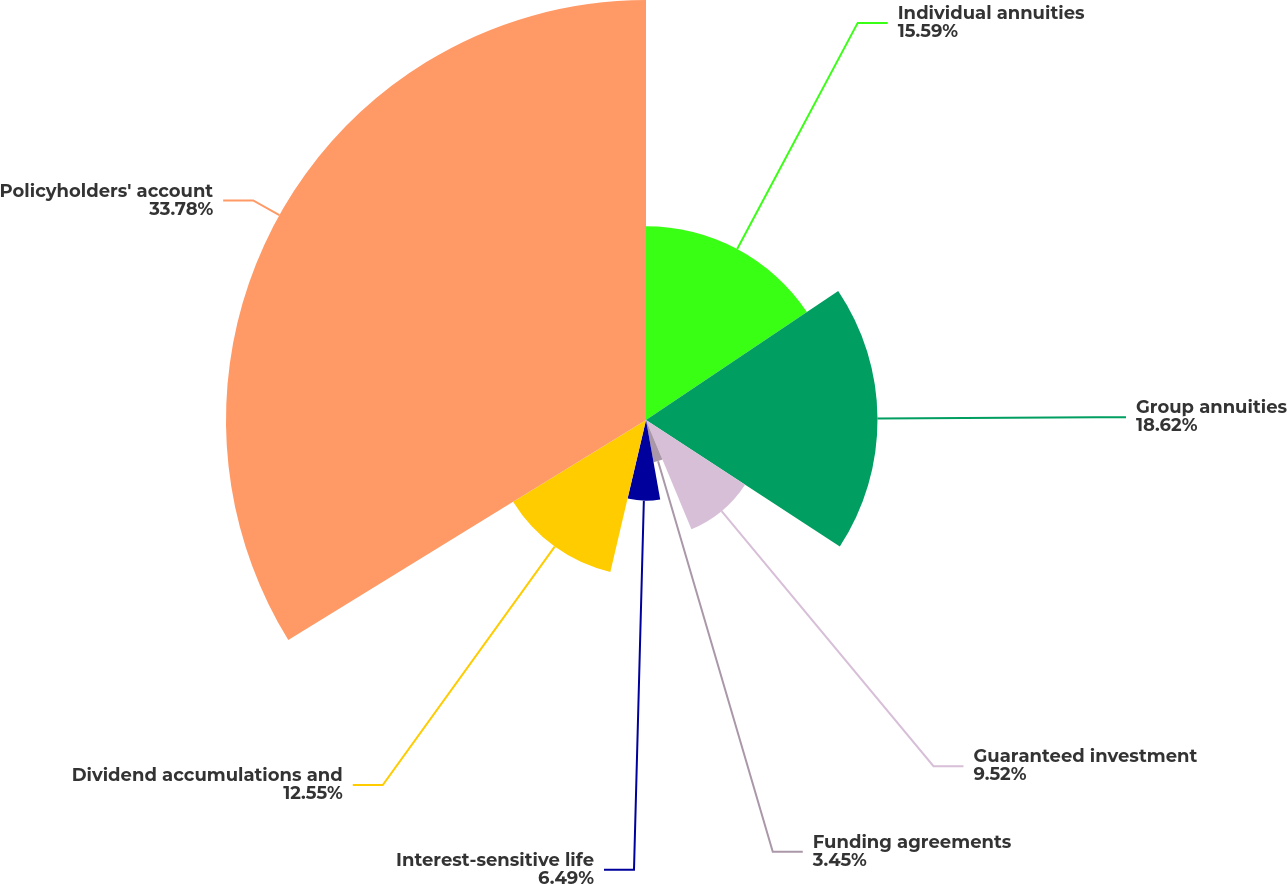<chart> <loc_0><loc_0><loc_500><loc_500><pie_chart><fcel>Individual annuities<fcel>Group annuities<fcel>Guaranteed investment<fcel>Funding agreements<fcel>Interest-sensitive life<fcel>Dividend accumulations and<fcel>Policyholders' account<nl><fcel>15.59%<fcel>18.62%<fcel>9.52%<fcel>3.45%<fcel>6.49%<fcel>12.55%<fcel>33.78%<nl></chart> 